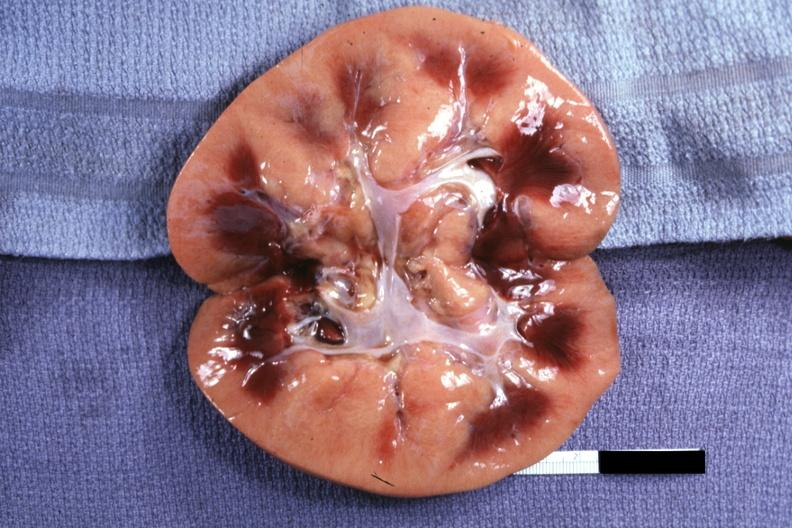does this image show obviously greatly swollen and pale kidney?
Answer the question using a single word or phrase. Yes 